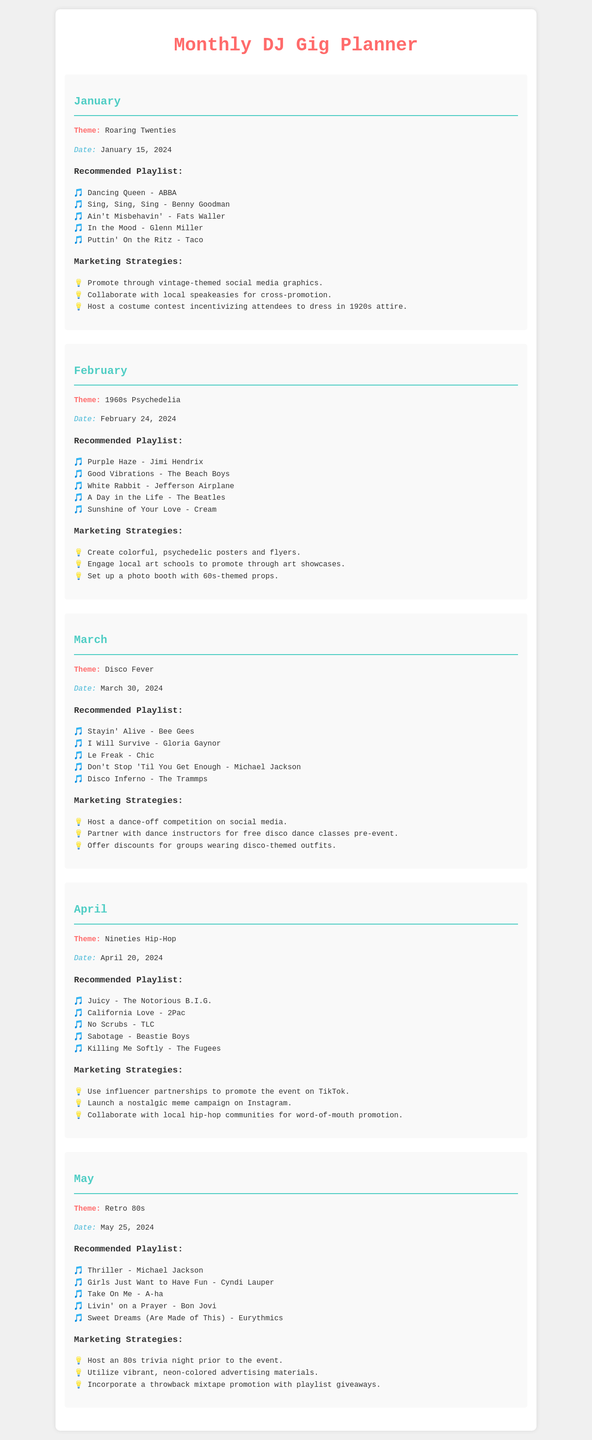what is the theme for January? The theme for January is the specific historical theme outlined for that month.
Answer: Roaring Twenties when is the February event scheduled? The event date is specified in the document for February.
Answer: February 24, 2024 name one song from the March playlist. The playlist for March includes various songs, and this asks for any of them.
Answer: Stayin' Alive - Bee Gees what marketing strategy is suggested for the April event? The document lists various marketing strategies for April, and this question seeks one example.
Answer: Use influencer partnerships to promote the event on TikTok how many songs are recommended for the May playlist? Each monthly playlist includes a set number of songs, and this question asks for that count.
Answer: Five what is the date for the Disco Fever event? The specific date of the Disco Fever event is mentioned in the document.
Answer: March 30, 2024 which decade does the May theme represent? This question targets finding the decade related to the theme provided for May.
Answer: 80s list one marketing strategy for the 1960s Psychedelia event. This question seeks a single example from the marketing strategies section for February's theme.
Answer: Create colorful, psychedelic posters and flyers 